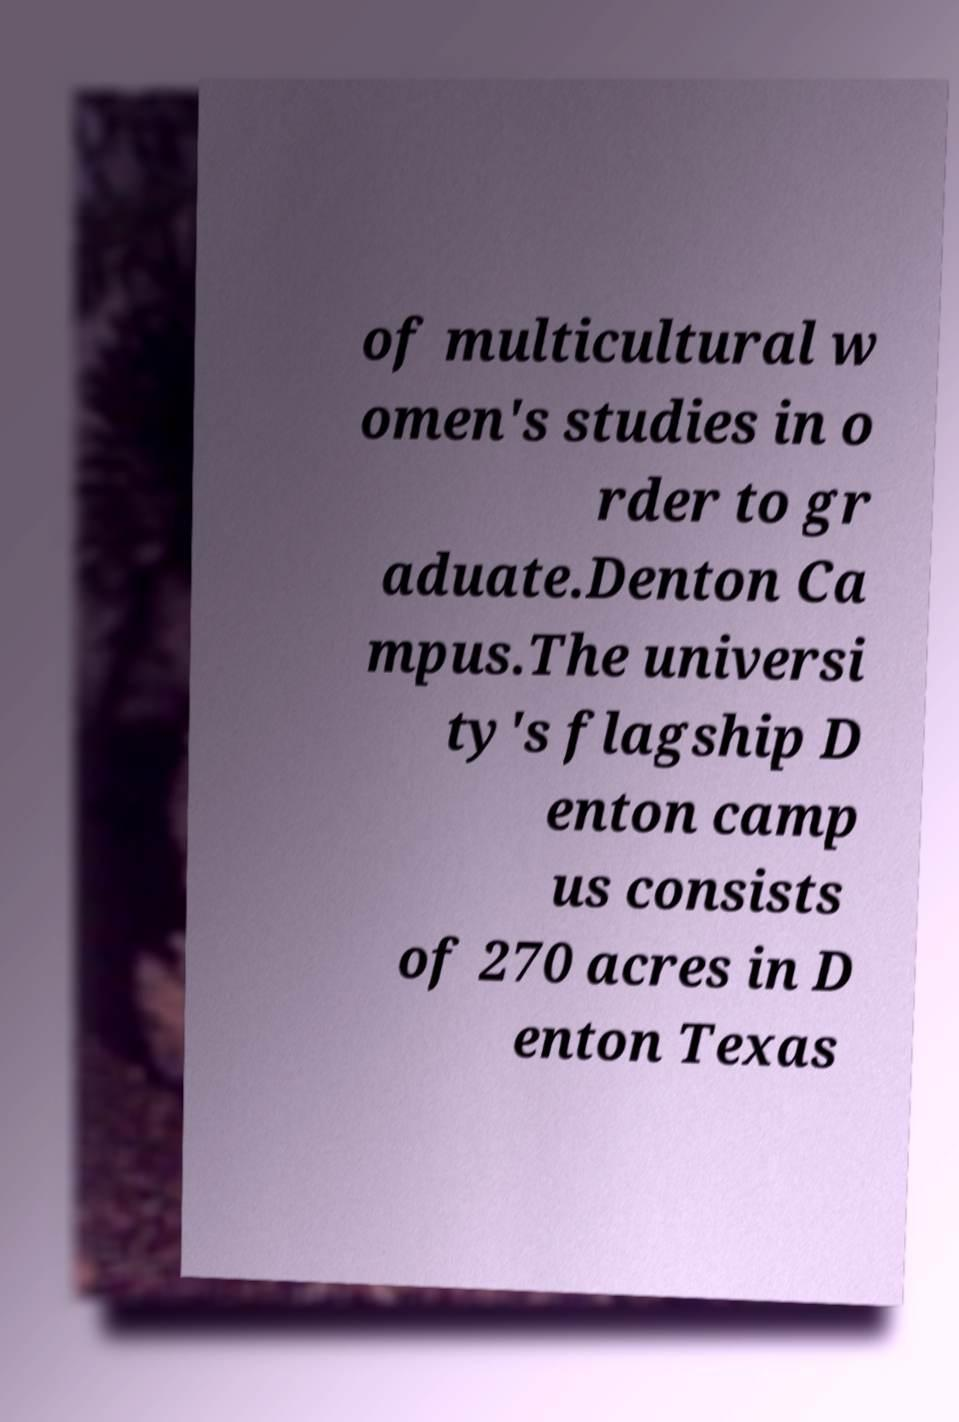Can you accurately transcribe the text from the provided image for me? of multicultural w omen's studies in o rder to gr aduate.Denton Ca mpus.The universi ty's flagship D enton camp us consists of 270 acres in D enton Texas 